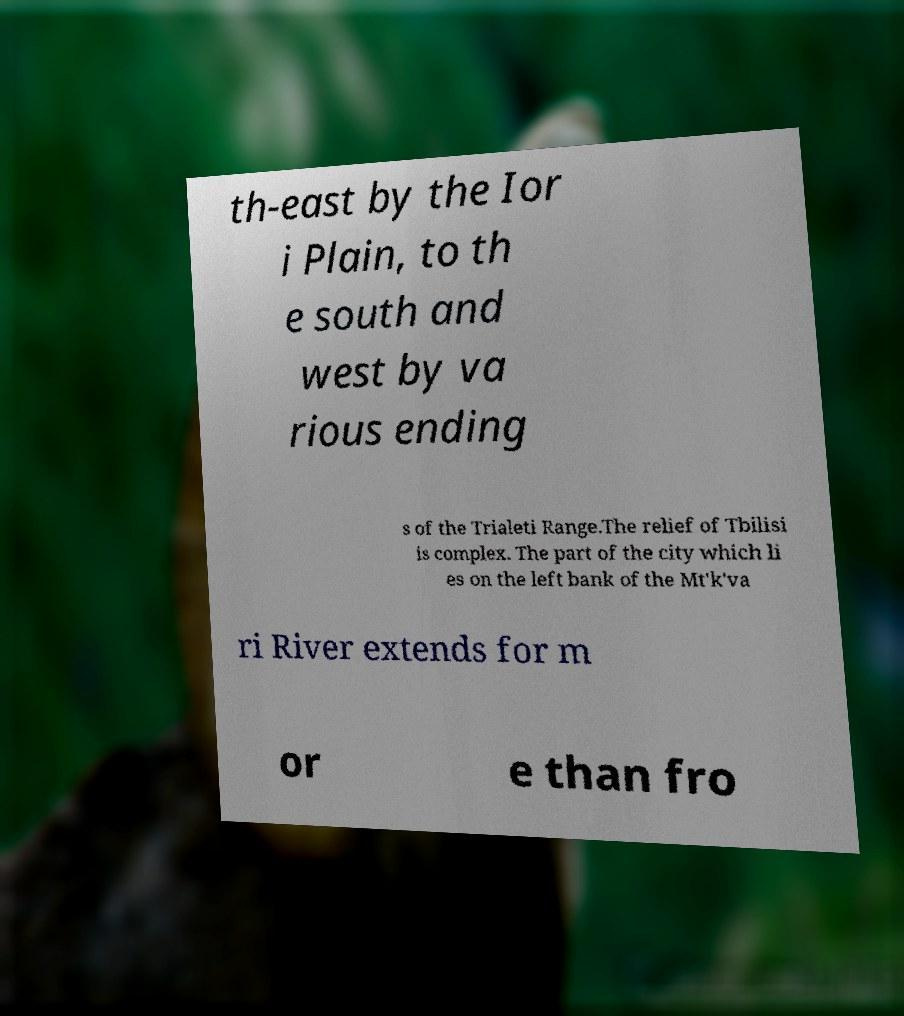For documentation purposes, I need the text within this image transcribed. Could you provide that? th-east by the Ior i Plain, to th e south and west by va rious ending s of the Trialeti Range.The relief of Tbilisi is complex. The part of the city which li es on the left bank of the Mt'k'va ri River extends for m or e than fro 